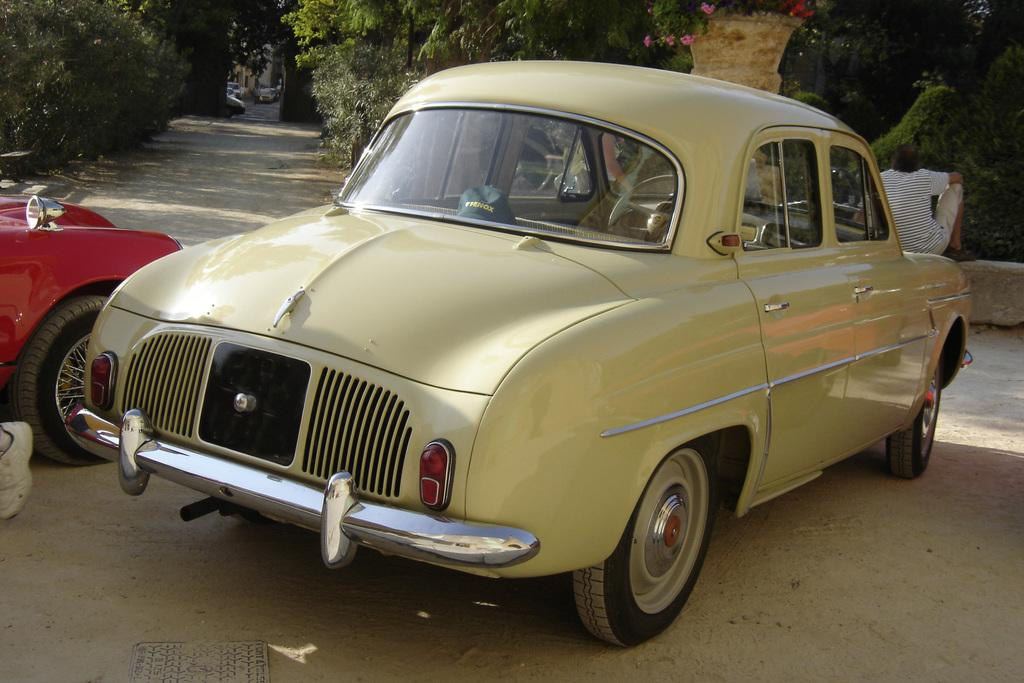What is the main subject of the image? There is a car in the image. Can you describe another vehicle in the image? There is another vehicle in the image, which is red in color. Where is the red vehicle located in relation to the car? The red vehicle is beside the car. Is there anyone visible in the image? Yes, there is a person sitting in the right corner of the image. What can be seen in the background of the image? There are trees in the background of the image. What type of shirt is the zephyr wearing in the image? There is no zephyr or person wearing a shirt in the image; it only features a car and another vehicle. How many matches are visible in the image? There are no matches present in the image. 